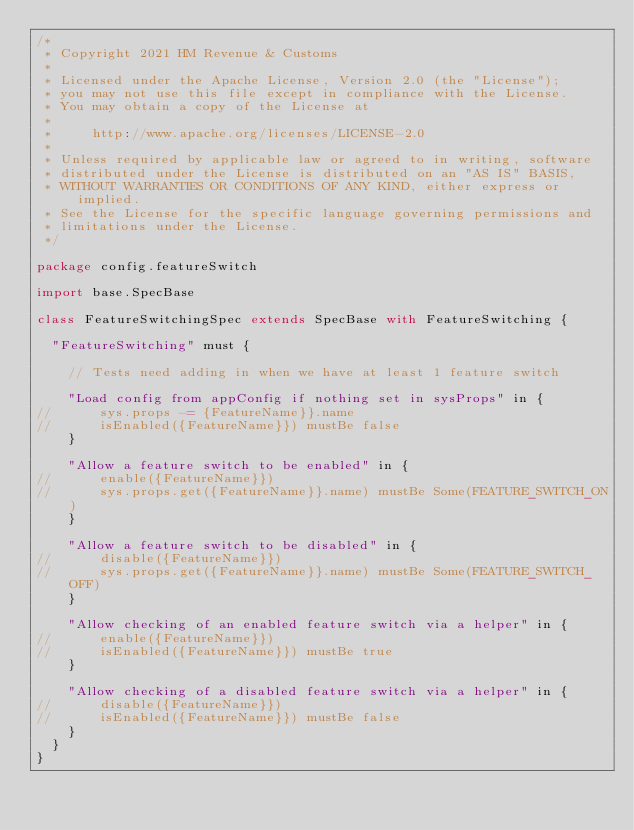Convert code to text. <code><loc_0><loc_0><loc_500><loc_500><_Scala_>/*
 * Copyright 2021 HM Revenue & Customs
 *
 * Licensed under the Apache License, Version 2.0 (the "License");
 * you may not use this file except in compliance with the License.
 * You may obtain a copy of the License at
 *
 *     http://www.apache.org/licenses/LICENSE-2.0
 *
 * Unless required by applicable law or agreed to in writing, software
 * distributed under the License is distributed on an "AS IS" BASIS,
 * WITHOUT WARRANTIES OR CONDITIONS OF ANY KIND, either express or implied.
 * See the License for the specific language governing permissions and
 * limitations under the License.
 */

package config.featureSwitch

import base.SpecBase

class FeatureSwitchingSpec extends SpecBase with FeatureSwitching {

  "FeatureSwitching" must {

    // Tests need adding in when we have at least 1 feature switch

    "Load config from appConfig if nothing set in sysProps" in {
//      sys.props -= {FeatureName}}.name
//      isEnabled({FeatureName}}) mustBe false
    }

    "Allow a feature switch to be enabled" in {
//      enable({FeatureName}})
//      sys.props.get({FeatureName}}.name) mustBe Some(FEATURE_SWITCH_ON)
    }

    "Allow a feature switch to be disabled" in {
//      disable({FeatureName}})
//      sys.props.get({FeatureName}}.name) mustBe Some(FEATURE_SWITCH_OFF)
    }

    "Allow checking of an enabled feature switch via a helper" in {
//      enable({FeatureName}})
//      isEnabled({FeatureName}}) mustBe true
    }

    "Allow checking of a disabled feature switch via a helper" in {
//      disable({FeatureName}})
//      isEnabled({FeatureName}}) mustBe false
    }
  }
}
</code> 